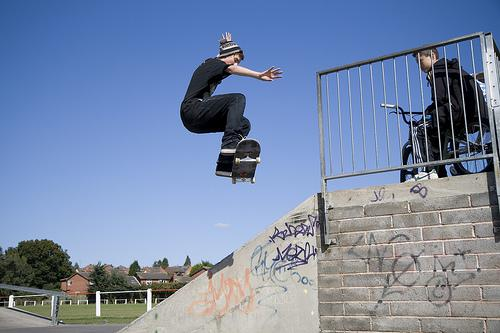Question: what is the person on the left doing?
Choices:
A. Surfing.
B. Skiing.
C. Laughing.
D. Skateboarding.
Answer with the letter. Answer: D Question: what are in the background?
Choices:
A. Trees.
B. Houses.
C. Cars.
D. A parking lot.
Answer with the letter. Answer: B Question: what is on the skateboarder's head?
Choices:
A. A flower.
B. An umbrella.
C. A toupe.
D. A hat.
Answer with the letter. Answer: D Question: how many bars are on the railing?
Choices:
A. 10.
B. 9.
C. 8.
D. 13.
Answer with the letter. Answer: D 